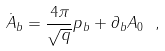<formula> <loc_0><loc_0><loc_500><loc_500>\dot { A } _ { b } = \frac { 4 \pi } { \sqrt { q } } p _ { b } + \partial _ { b } A _ { 0 } \ ,</formula> 